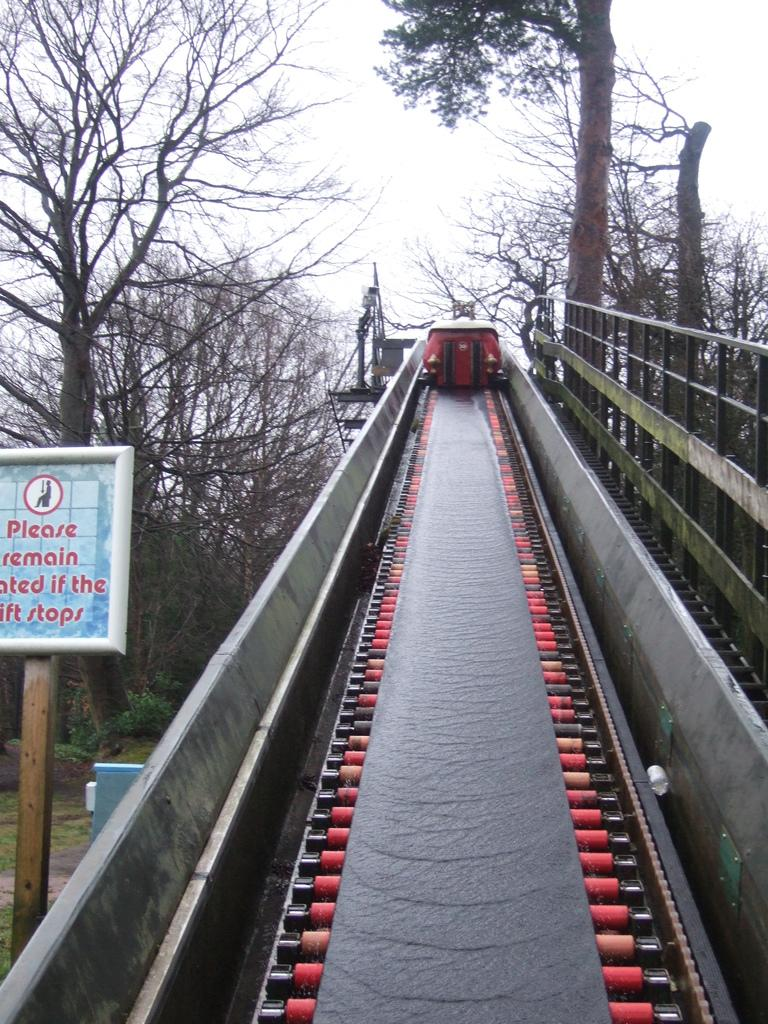What is the main structure in the center of the image? There is a lift in the center of the image. What can be seen on the right side of the image? There is hand railing on the right side of the image. What is on the left side of the image? There is a board on the left side of the image. What is visible in the background of the image? Trees and the sky are visible in the background of the image. What type of drum can be seen in the image? There is no drum present in the image. Is there a shop visible in the image? There is no shop visible in the image. 